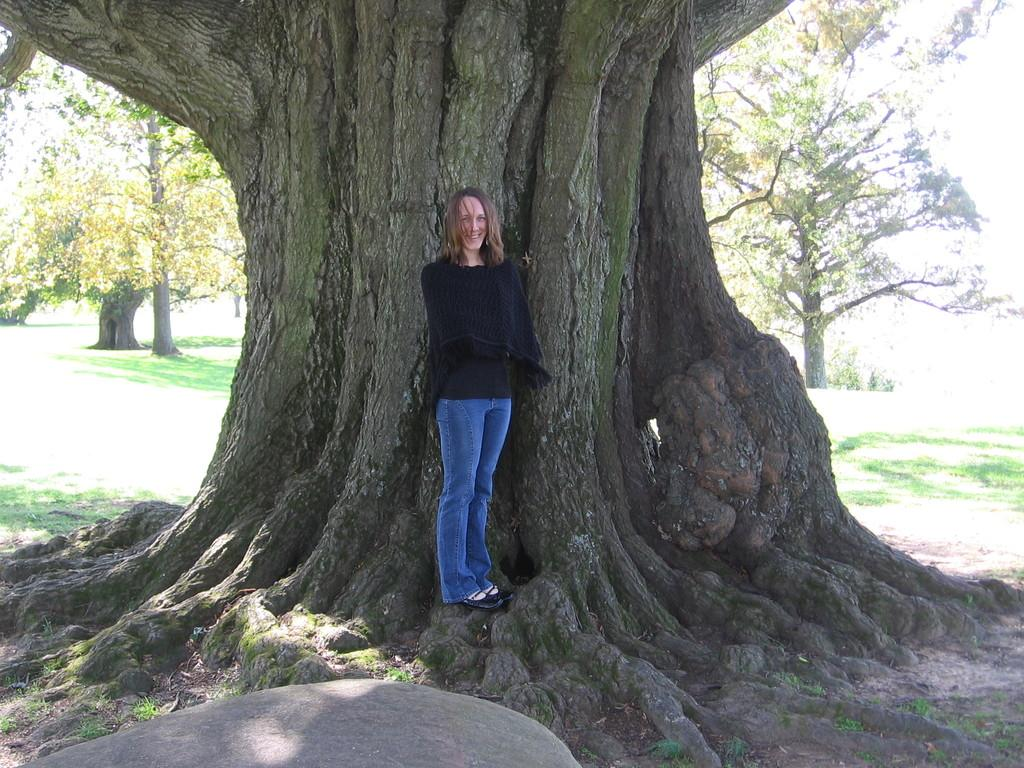What object can be seen in the image? There is a stone in the image. Who is present in the image? There is a woman standing in the image. What is the woman's expression? The woman is smiling. What type of vegetation can be seen in the background of the image? There is grass and trees visible in the background of the image. What type of quince is the woman holding in the image? There is no quince present in the image; it features a woman standing near a stone. Is the woman wearing stockings in the image? The image does not provide information about the woman's clothing, so it cannot be determined if she is wearing stockings. 